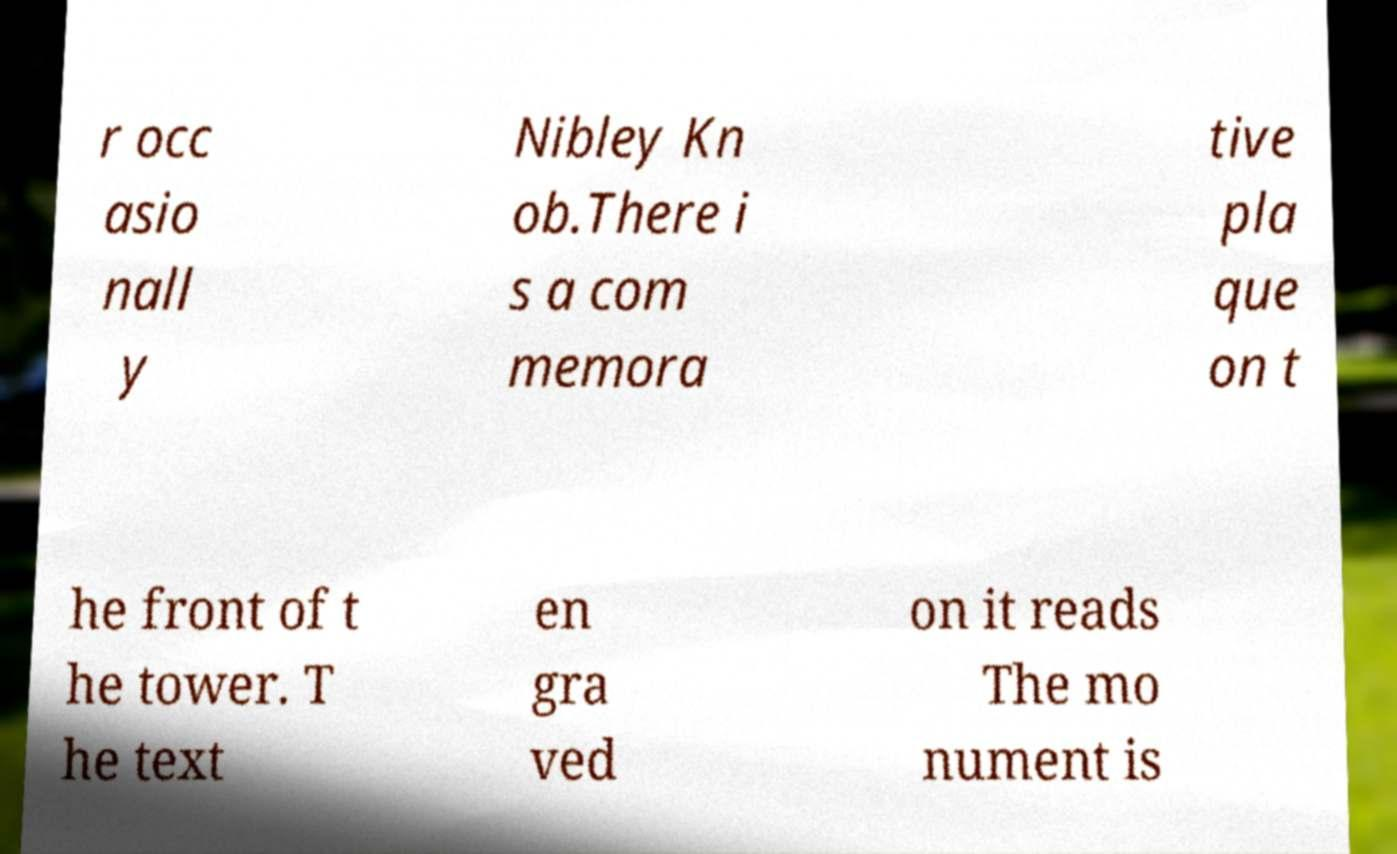I need the written content from this picture converted into text. Can you do that? r occ asio nall y Nibley Kn ob.There i s a com memora tive pla que on t he front of t he tower. T he text en gra ved on it reads The mo nument is 